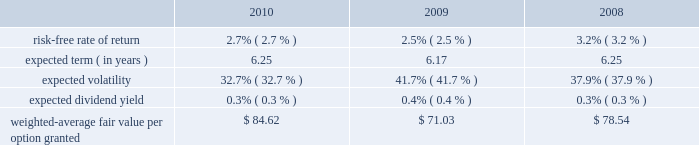Mastercard incorporated notes to consolidated financial statements 2014continued in september 2010 , the company 2019s board of directors authorized a plan for the company to repurchase up to $ 1 billion of its class a common stock in open market transactions .
The company did not repurchase any shares under this plan during 2010 .
As of february 16 , 2011 , the company had completed the repurchase of approximately 0.3 million shares of its class a common stock at a cost of approximately $ 75 million .
Note 18 .
Share based payment and other benefits in may 2006 , the company implemented the mastercard incorporated 2006 long-term incentive plan , which was amended and restated as of october 13 , 2008 ( the 201cltip 201d ) .
The ltip is a shareholder-approved omnibus plan that permits the grant of various types of equity awards to employees .
The company has granted restricted stock units ( 201crsus 201d ) , non-qualified stock options ( 201coptions 201d ) and performance stock units ( 201cpsus 201d ) under the ltip .
The rsus generally vest after three to four years .
The options , which expire ten years from the date of grant , generally vest ratably over four years from the date of grant .
The psus generally vest after three years .
Additionally , the company made a one-time grant to all non-executive management employees upon the ipo for a total of approximately 440 thousand rsus ( the 201cfounders 2019 grant 201d ) .
The founders 2019 grant rsus vested three years from the date of grant .
The company uses the straight-line method of attribution for expensing equity awards .
Compensation expense is recorded net of estimated forfeitures .
Estimates are adjusted as appropriate .
Upon termination of employment , excluding retirement , all of a participant 2019s unvested awards are forfeited .
However , when a participant terminates employment due to retirement , the participant generally retains all of their awards without providing additional service to the company .
Eligible retirement is dependent upon age and years of service , as follows : age 55 with ten years of service , age 60 with five years of service and age 65 with two years of service .
Compensation expense is recognized over the shorter of the vesting periods stated in the ltip , or the date the individual becomes eligible to retire .
There are 11550000 shares of class a common stock reserved for equity awards under the ltip .
Although the ltip permits the issuance of shares of class b common stock , no such shares have been reserved for issuance .
Shares issued as a result of option exercises and the conversions of rsus and psus are expected to be funded primarily with the issuance of new shares of class a common stock .
Stock options the fair value of each option is estimated on the date of grant using a black-scholes option pricing model .
The table presents the weighted-average assumptions used in the valuation and the resulting weighted- average fair value per option granted for the years ended december 31: .
The risk-free rate of return was based on the u.s .
Treasury yield curve in effect on the date of grant .
The company utilizes the simplified method for calculating the expected term of the option based on the vesting terms and the contractual life of the option .
The expected volatility for options granted during 2010 and 2009 was based on the average of the implied volatility of mastercard and a blend of the historical volatility of mastercard and the historical volatility of a group of companies that management believes is generally comparable to .
What was the percentage change in the risk-free rate of return from 2009 to 2010? 
Rationale: the risk-free rate of return increased by 8% from 2009 to 2010
Computations: ((2.7 - 2.5) / 2.5)
Answer: 0.08. 